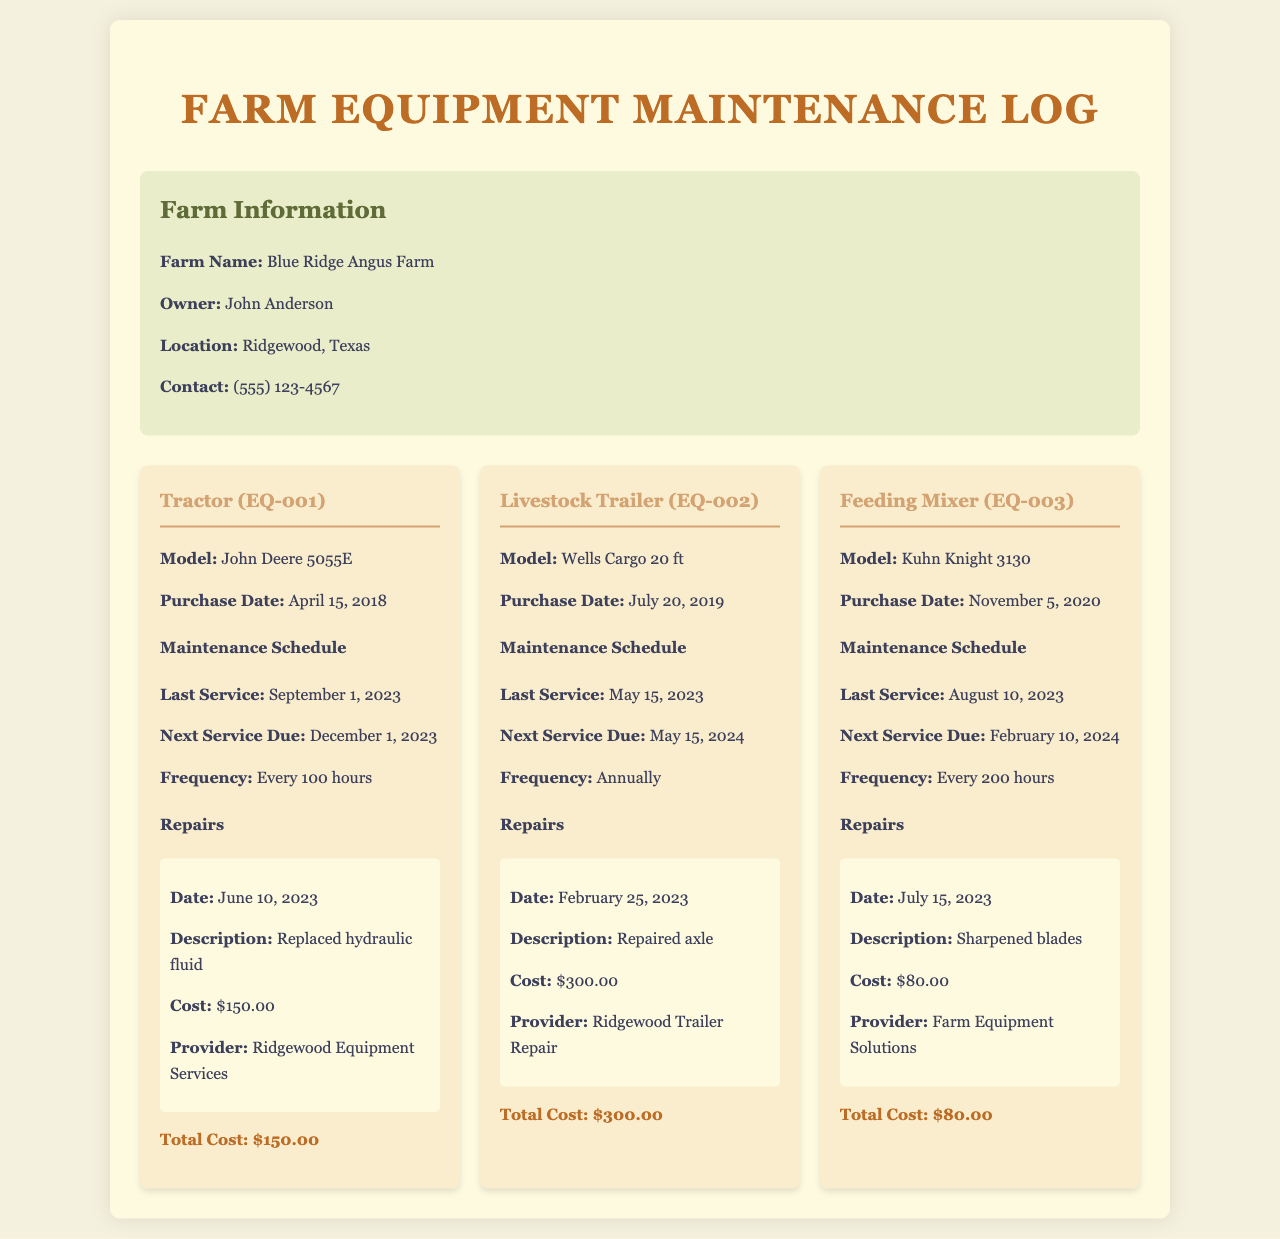what is the farm name? The farm name is indicated prominently at the beginning of the document under farm information.
Answer: Blue Ridge Angus Farm who is the owner of the farm? The owner's name is provided in the farm information section of the document.
Answer: John Anderson when was the last service performed on the tractor? The date of the last service is listed in the maintenance schedule for the tractor.
Answer: September 1, 2023 what was the cost of the repair for the livestock trailer? The cost of the repair is mentioned specifically in the repairs section under the livestock trailer.
Answer: $300.00 what is the next service due for the feeding mixer? The next service due is provided in the maintenance schedule for the feeding mixer.
Answer: February 10, 2024 how often is the tractor serviced? The frequency of service for the tractor can be found in its maintenance schedule.
Answer: Every 100 hours what type of equipment has had a repair for sharpening blades? The repair for sharpening blades is mentioned under the repairs section for specific equipment.
Answer: Feeding Mixer how many total costs are listed for the equipment? The total costs for each piece of equipment are outlined individually in their respective sections.
Answer: Three total costs what is the location of the farm? The location of the farm is specified in the farm information section of the document.
Answer: Ridgewood, Texas 